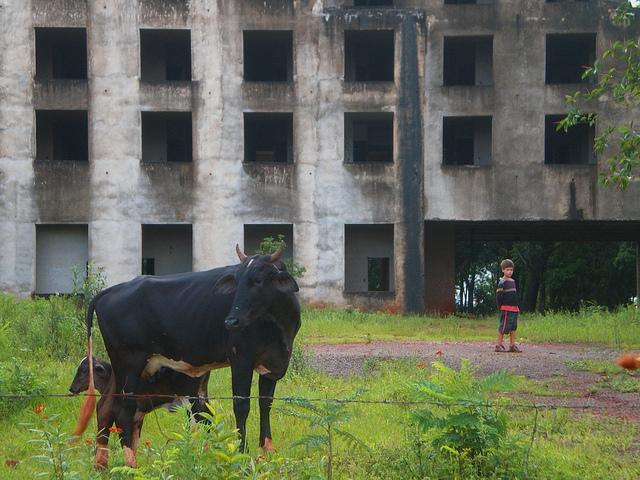What animals is the child looking at?
Indicate the correct response by choosing from the four available options to answer the question.
Options: Cats, deer, beavers, cows. Cows. 